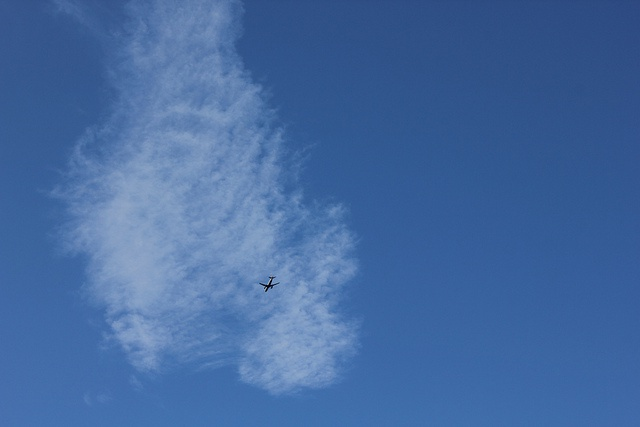Describe the objects in this image and their specific colors. I can see a airplane in blue, black, gray, darkgray, and navy tones in this image. 